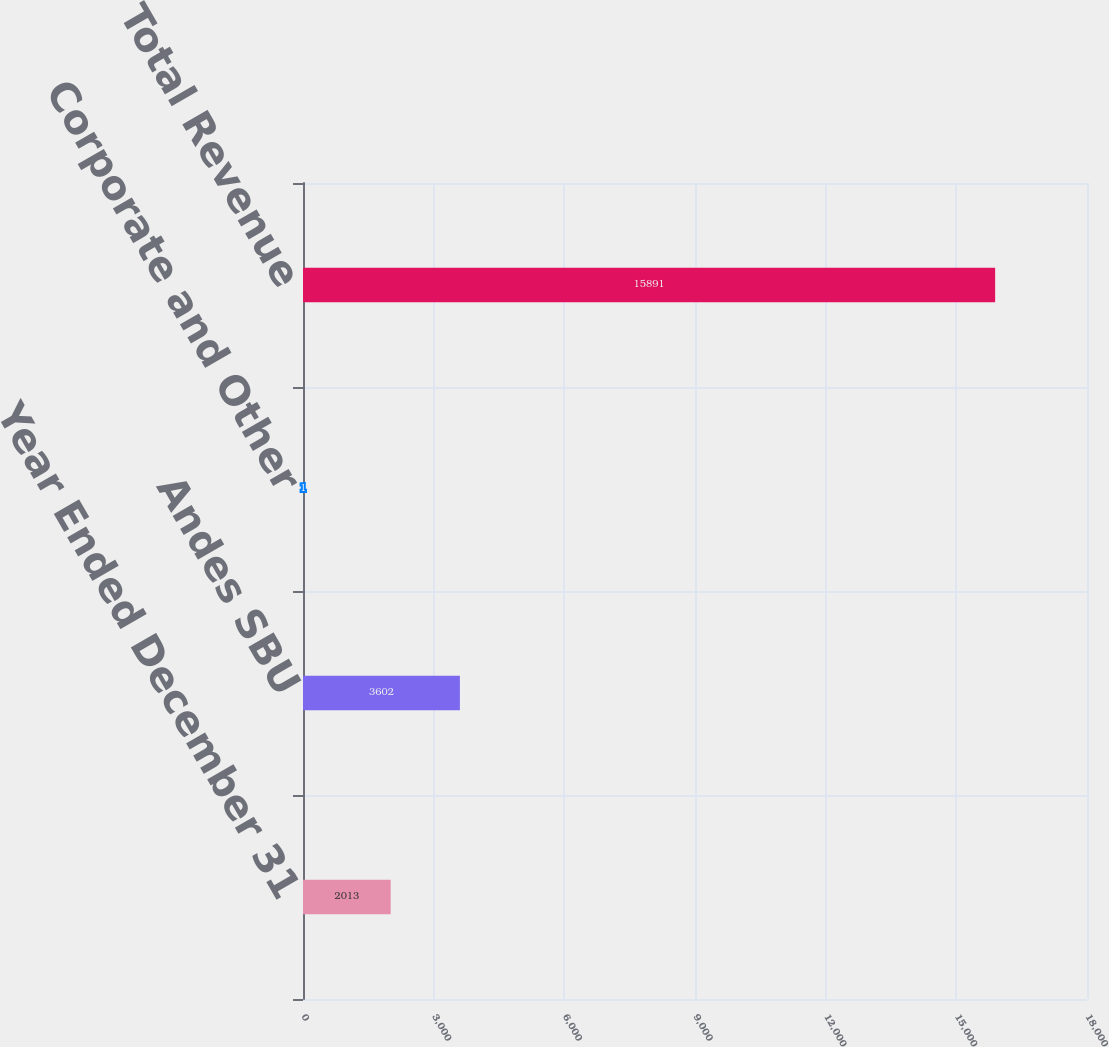Convert chart to OTSL. <chart><loc_0><loc_0><loc_500><loc_500><bar_chart><fcel>Year Ended December 31<fcel>Andes SBU<fcel>Corporate and Other<fcel>Total Revenue<nl><fcel>2013<fcel>3602<fcel>1<fcel>15891<nl></chart> 